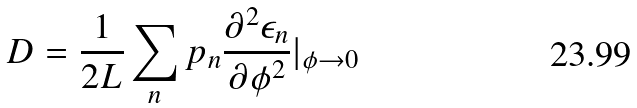<formula> <loc_0><loc_0><loc_500><loc_500>D = \frac { 1 } { 2 L } \sum _ { n } p _ { n } \frac { \partial ^ { 2 } \epsilon _ { n } } { \partial \phi ^ { 2 } } | _ { \phi \rightarrow 0 }</formula> 